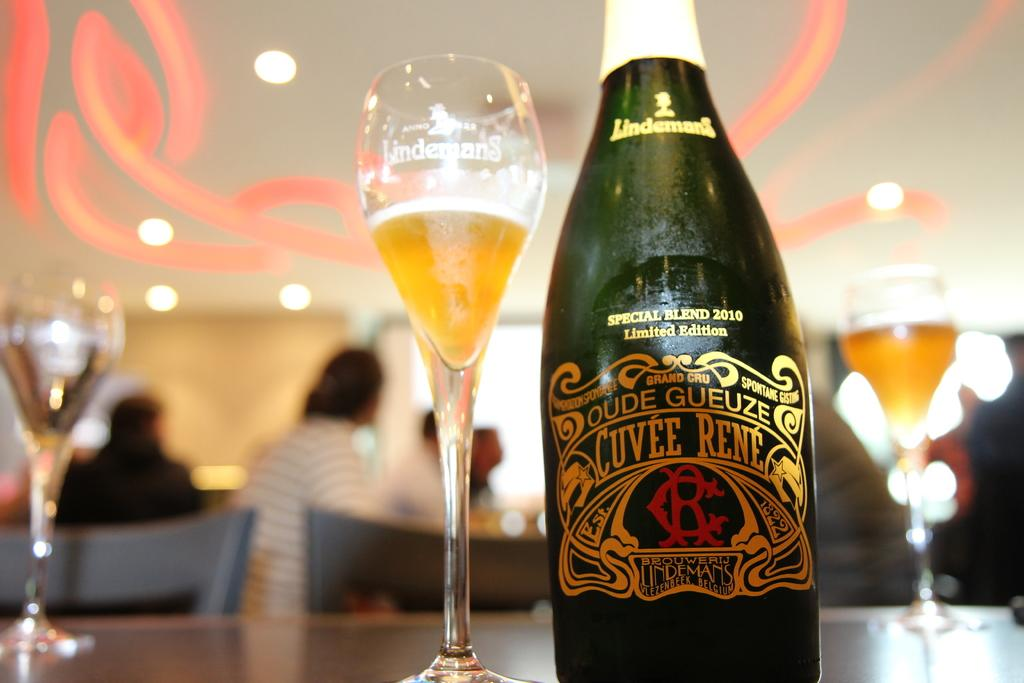<image>
Render a clear and concise summary of the photo. A bottle of oude gueze next to glasses with liquid in there 